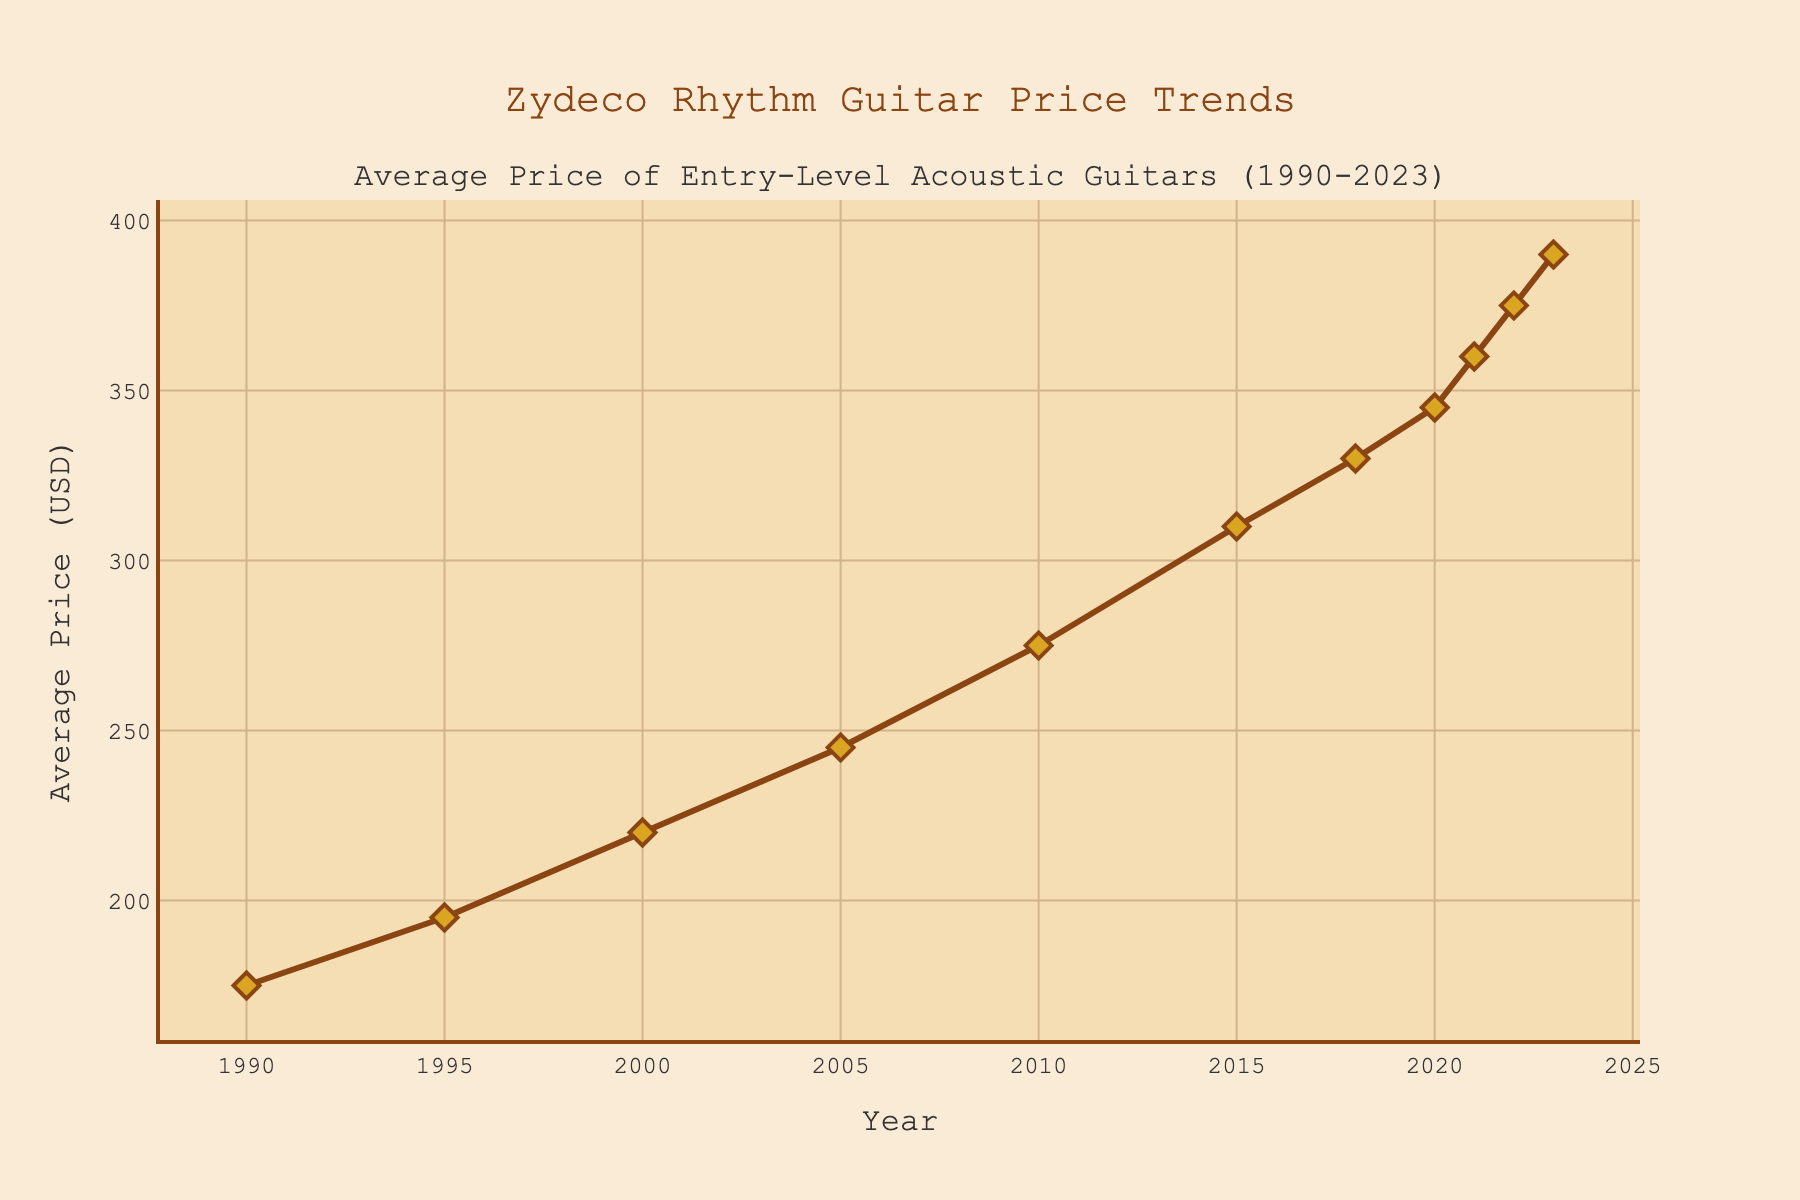What was the average price of entry-level acoustic guitars in 2010? In the figure, locate the point corresponding to the year 2010 and read the value on the y-axis.
Answer: 275 USD How much did the average price increase between 1990 and 2023? Find the average prices in 1990 and 2023 from the chart (175 USD and 390 USD respectively), then subtract the 1990 value from the 2023 value: 390 - 175 = 215.
Answer: 215 USD In which year did the average price first exceed 300 USD? Locate the points on the chart and follow the y-axis to identify the first year where the average price is above 300 USD.
Answer: 2015 By how much did the price change between 2018 and 2022? Find the average prices for 2018 and 2022 (330 USD and 375 USD respectively), then subtract the 2018 value from the 2022 value: 375 - 330 = 45.
Answer: 45 USD What is the overall trend of the average price from 1990 to 2023? Observe the general movement of the line representing the average price across the years. The line consistently rises over time, indicating an increasing trend.
Answer: Increasing What was the difference in average price between 1995 and 2000? Look at the average prices for 1995 and 2000 from the chart (195 USD and 220 USD respectively) and subtract the 1995 value from the 2000 value: 220 - 195 = 25.
Answer: 25 USD Between the years 2005 and 2015, how much did the average price increase? Find the average prices for 2005 and 2015 (245 USD and 310 USD respectively), then subtract the 2005 value from the 2015 value: 310 - 245 = 65.
Answer: 65 USD What is the average price for the years 2010, 2015, and 2020? Sum the average prices for the given years (275 USD + 310 USD + 345 USD) and then divide by the number of years (3): (275 + 310 + 345) / 3 = 310.
Answer: 310 USD 